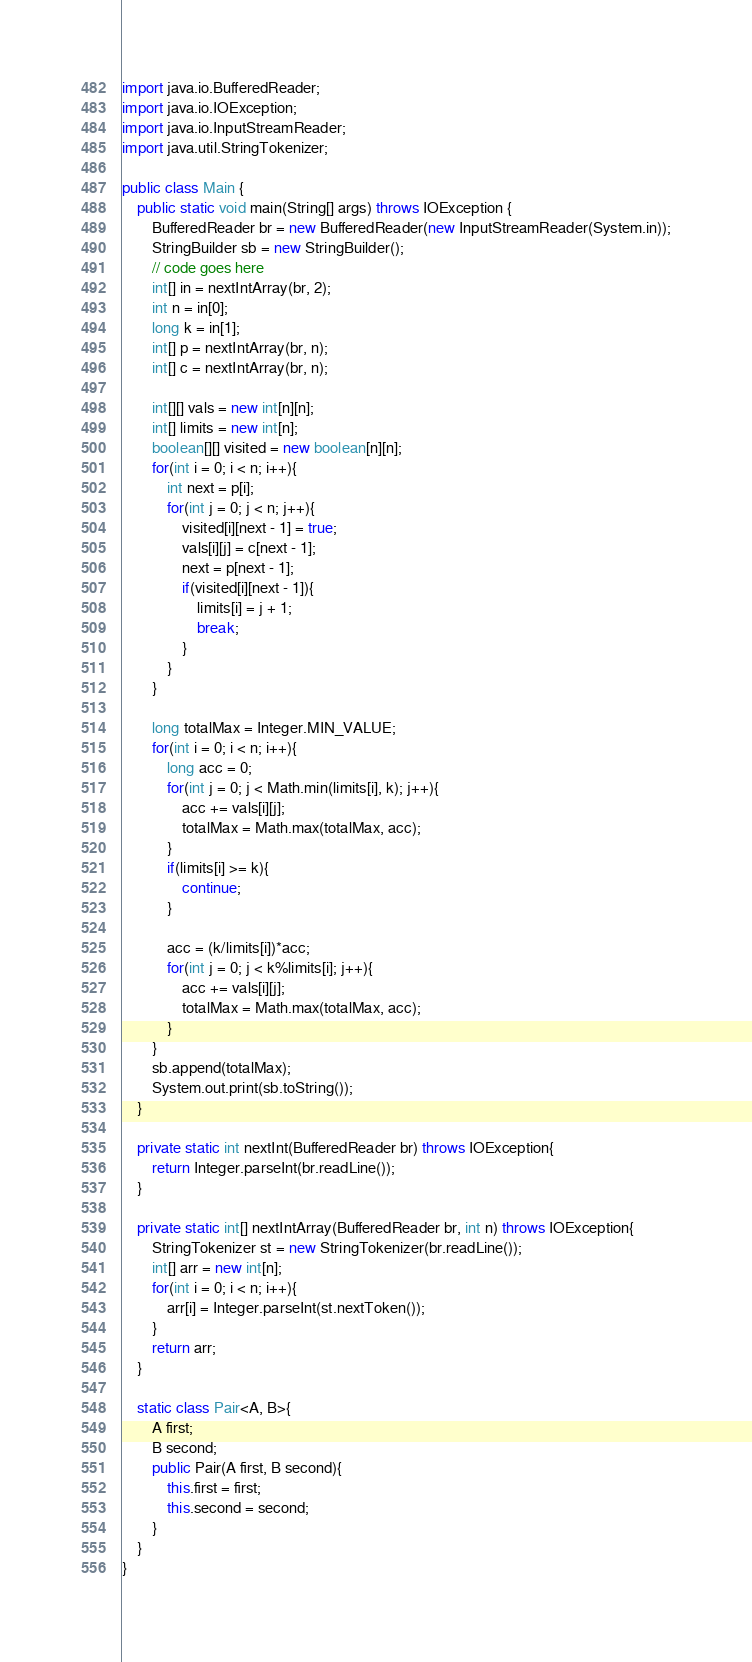<code> <loc_0><loc_0><loc_500><loc_500><_Java_>
import java.io.BufferedReader;
import java.io.IOException;
import java.io.InputStreamReader;
import java.util.StringTokenizer;

public class Main {
    public static void main(String[] args) throws IOException {
        BufferedReader br = new BufferedReader(new InputStreamReader(System.in));
        StringBuilder sb = new StringBuilder();
        // code goes here
        int[] in = nextIntArray(br, 2);
        int n = in[0];
        long k = in[1];
        int[] p = nextIntArray(br, n);
        int[] c = nextIntArray(br, n);

        int[][] vals = new int[n][n];
        int[] limits = new int[n];
        boolean[][] visited = new boolean[n][n];
        for(int i = 0; i < n; i++){
            int next = p[i];
            for(int j = 0; j < n; j++){
                visited[i][next - 1] = true;
                vals[i][j] = c[next - 1];
                next = p[next - 1];
                if(visited[i][next - 1]){
                    limits[i] = j + 1;
                    break;
                }
            }
        }

        long totalMax = Integer.MIN_VALUE;
        for(int i = 0; i < n; i++){
            long acc = 0;
            for(int j = 0; j < Math.min(limits[i], k); j++){
                acc += vals[i][j];
                totalMax = Math.max(totalMax, acc);
            }
            if(limits[i] >= k){
                continue;
            }

            acc = (k/limits[i])*acc;
            for(int j = 0; j < k%limits[i]; j++){
                acc += vals[i][j];
                totalMax = Math.max(totalMax, acc);
            }
        }
        sb.append(totalMax);
        System.out.print(sb.toString());
    }

    private static int nextInt(BufferedReader br) throws IOException{
        return Integer.parseInt(br.readLine());
    }

    private static int[] nextIntArray(BufferedReader br, int n) throws IOException{
        StringTokenizer st = new StringTokenizer(br.readLine());
        int[] arr = new int[n];
        for(int i = 0; i < n; i++){
            arr[i] = Integer.parseInt(st.nextToken());
        }
        return arr;
    }

    static class Pair<A, B>{
        A first;
        B second;
        public Pair(A first, B second){
            this.first = first;
            this.second = second;
        }
    }
}
</code> 